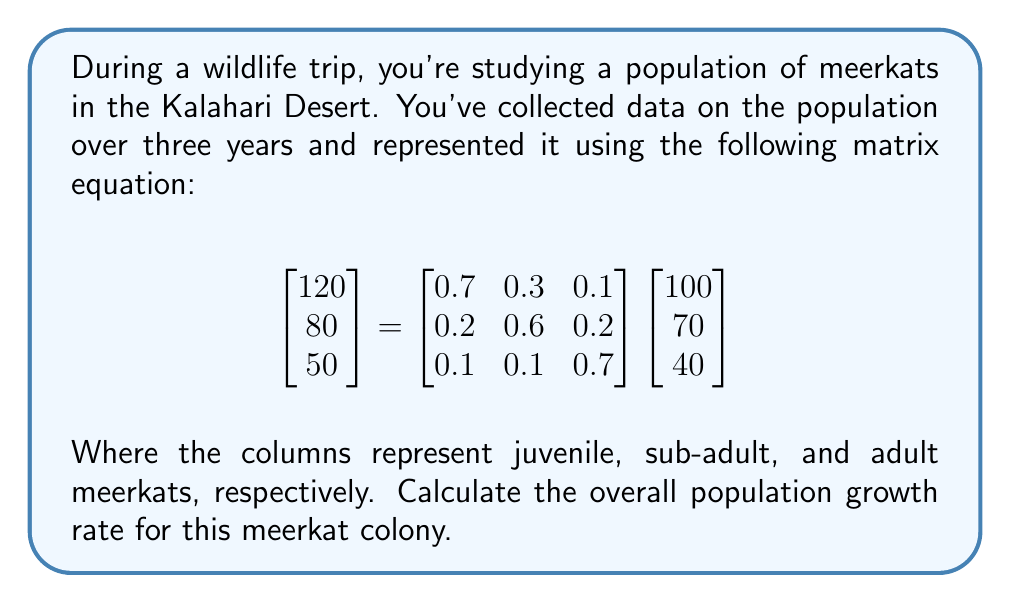Can you solve this math problem? To solve this problem, we'll follow these steps:

1) First, we need to understand what the matrix equation represents. The left vector shows the population after one year, while the right vector shows the initial population. The matrix in the middle is the transition matrix, showing how individuals move between age classes and reproduce.

2) To calculate the overall growth rate, we need to find the total population before and after:

   Initial total population: $100 + 70 + 40 = 210$
   Final total population: $120 + 80 + 50 = 250$

3) The growth rate is the ratio of the final population to the initial population:

   Growth rate = $\frac{\text{Final population}}{\text{Initial population}}$

4) Plugging in our values:

   Growth rate = $\frac{250}{210}$

5) Simplifying:

   Growth rate $\approx 1.1905$

6) To express this as a percentage increase, we subtract 1 and multiply by 100:

   Percentage increase = $(1.1905 - 1) \times 100 \approx 19.05\%$

Therefore, the population growth rate is approximately 19.05% per year.
Answer: 19.05% 